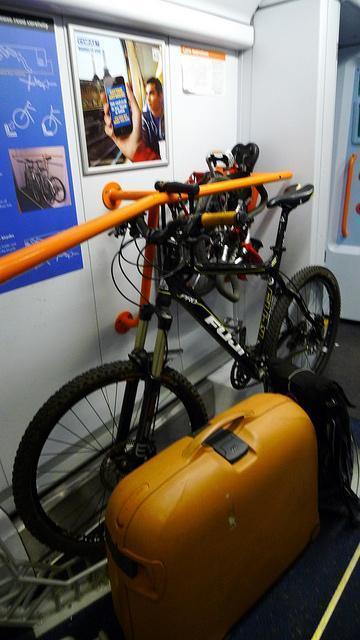How many zebras are lying down?
Give a very brief answer. 0. 